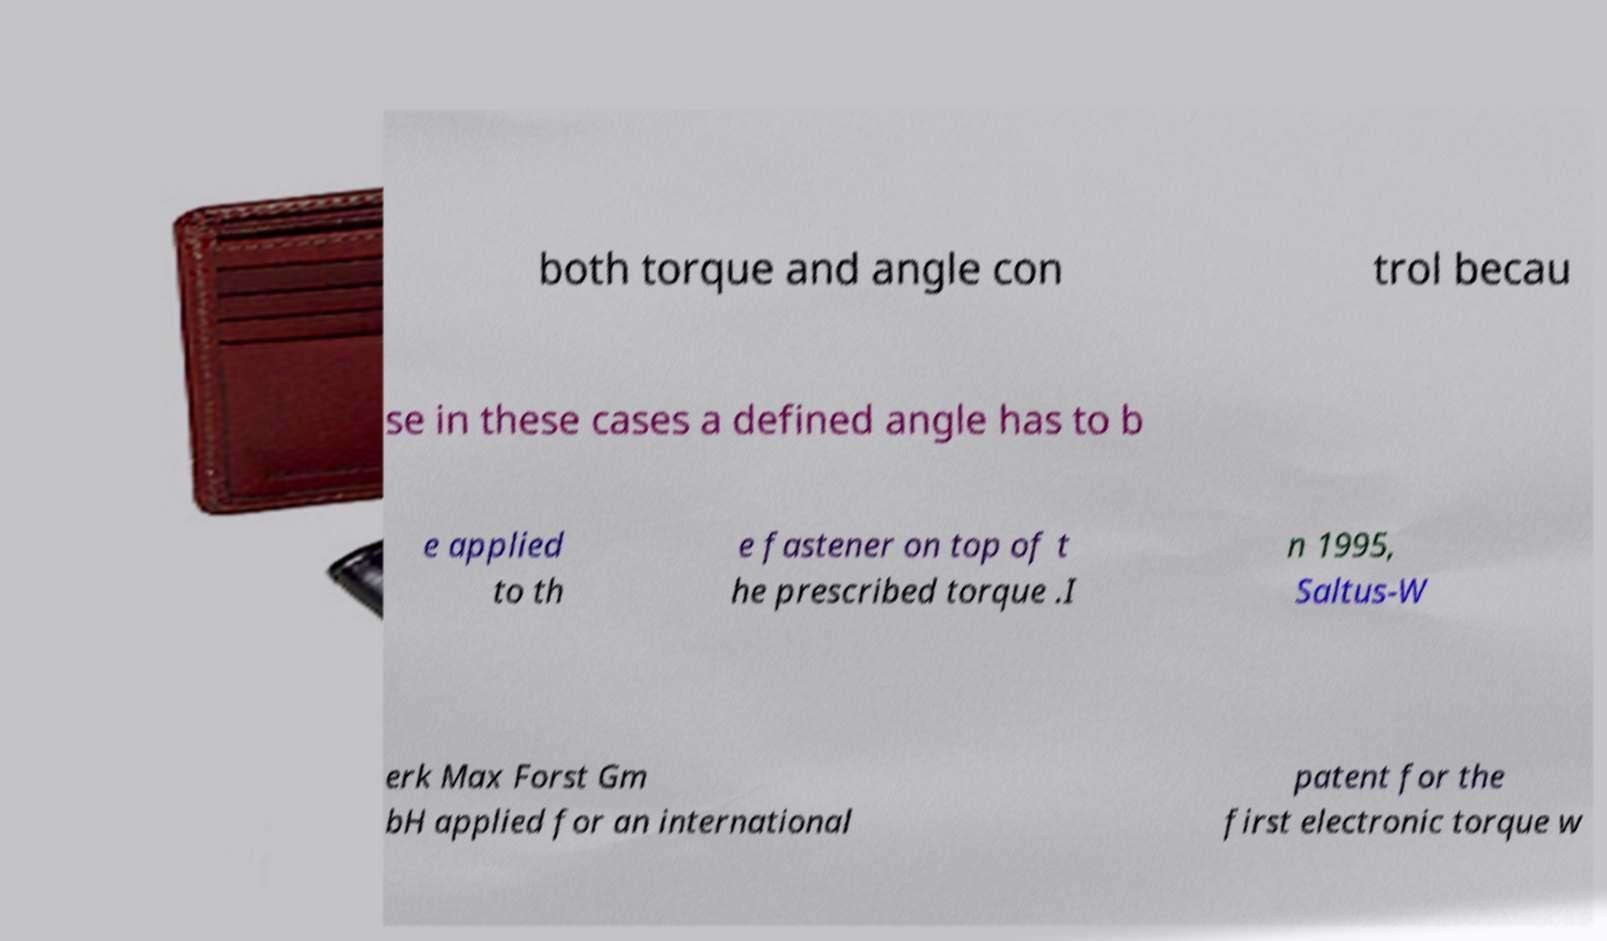Can you read and provide the text displayed in the image?This photo seems to have some interesting text. Can you extract and type it out for me? both torque and angle con trol becau se in these cases a defined angle has to b e applied to th e fastener on top of t he prescribed torque .I n 1995, Saltus-W erk Max Forst Gm bH applied for an international patent for the first electronic torque w 